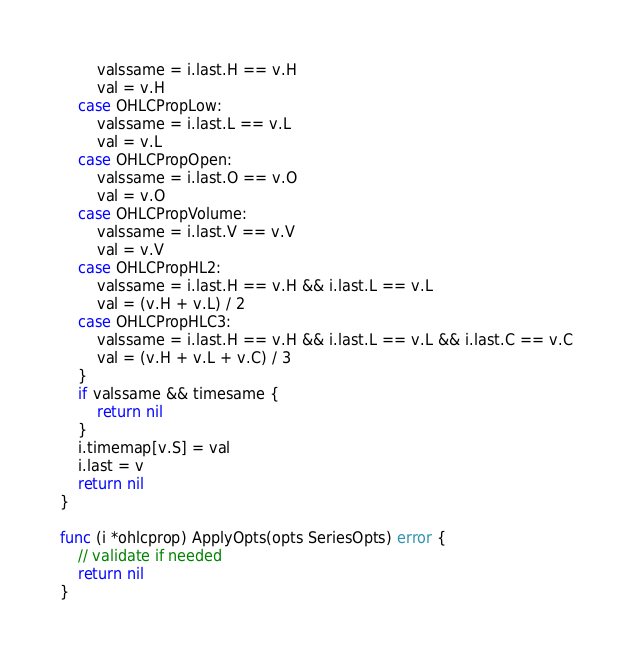<code> <loc_0><loc_0><loc_500><loc_500><_Go_>		valssame = i.last.H == v.H
		val = v.H
	case OHLCPropLow:
		valssame = i.last.L == v.L
		val = v.L
	case OHLCPropOpen:
		valssame = i.last.O == v.O
		val = v.O
	case OHLCPropVolume:
		valssame = i.last.V == v.V
		val = v.V
	case OHLCPropHL2:
		valssame = i.last.H == v.H && i.last.L == v.L
		val = (v.H + v.L) / 2
	case OHLCPropHLC3:
		valssame = i.last.H == v.H && i.last.L == v.L && i.last.C == v.C
		val = (v.H + v.L + v.C) / 3
	}
	if valssame && timesame {
		return nil
	}
	i.timemap[v.S] = val
	i.last = v
	return nil
}

func (i *ohlcprop) ApplyOpts(opts SeriesOpts) error {
	// validate if needed
	return nil
}
</code> 